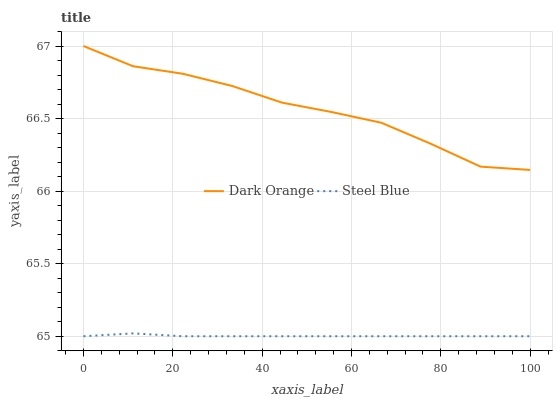Does Steel Blue have the minimum area under the curve?
Answer yes or no. Yes. Does Dark Orange have the maximum area under the curve?
Answer yes or no. Yes. Does Steel Blue have the maximum area under the curve?
Answer yes or no. No. Is Steel Blue the smoothest?
Answer yes or no. Yes. Is Dark Orange the roughest?
Answer yes or no. Yes. Is Steel Blue the roughest?
Answer yes or no. No. Does Steel Blue have the lowest value?
Answer yes or no. Yes. Does Dark Orange have the highest value?
Answer yes or no. Yes. Does Steel Blue have the highest value?
Answer yes or no. No. Is Steel Blue less than Dark Orange?
Answer yes or no. Yes. Is Dark Orange greater than Steel Blue?
Answer yes or no. Yes. Does Steel Blue intersect Dark Orange?
Answer yes or no. No. 